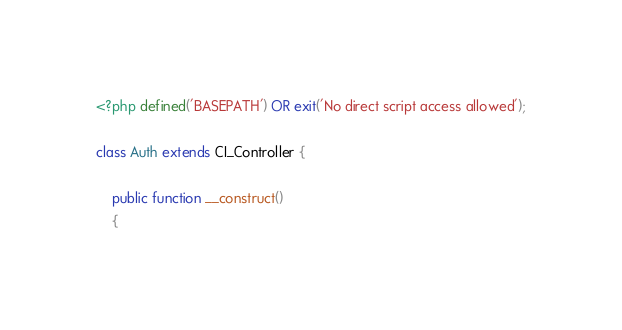Convert code to text. <code><loc_0><loc_0><loc_500><loc_500><_PHP_><?php defined('BASEPATH') OR exit('No direct script access allowed');

class Auth extends CI_Controller {

	public function __construct()
	{</code> 